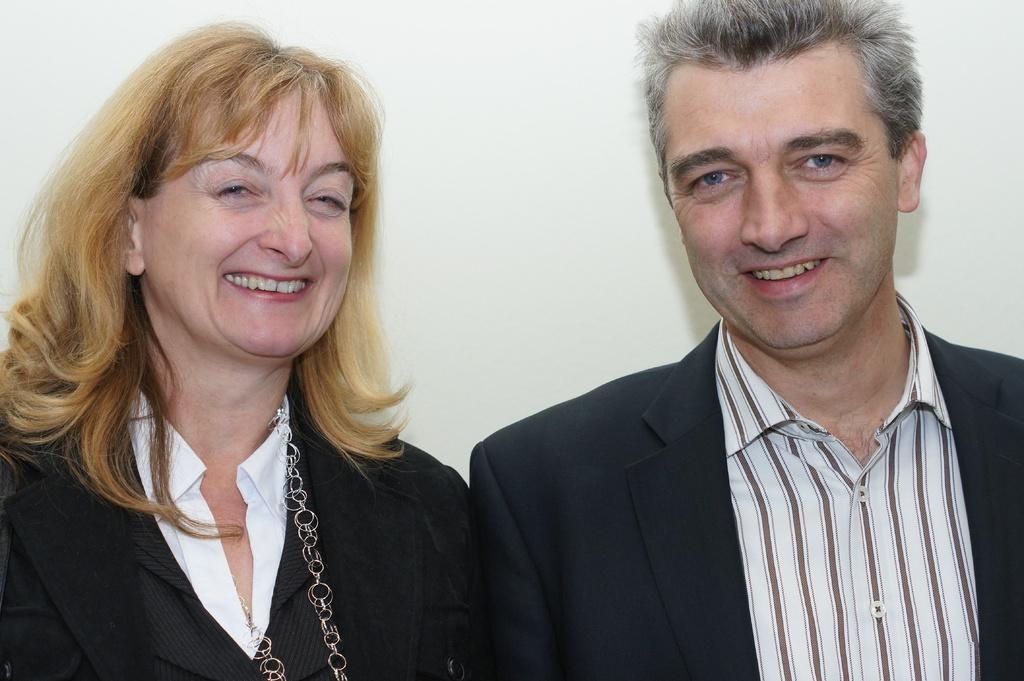What are the genders of the people in the image? There is a man and a woman in the image. What expressions do the people in the image have? The man and the woman are both smiling. What type of flower is the man holding in the image? There is no flower present in the image; the man is not holding anything. 